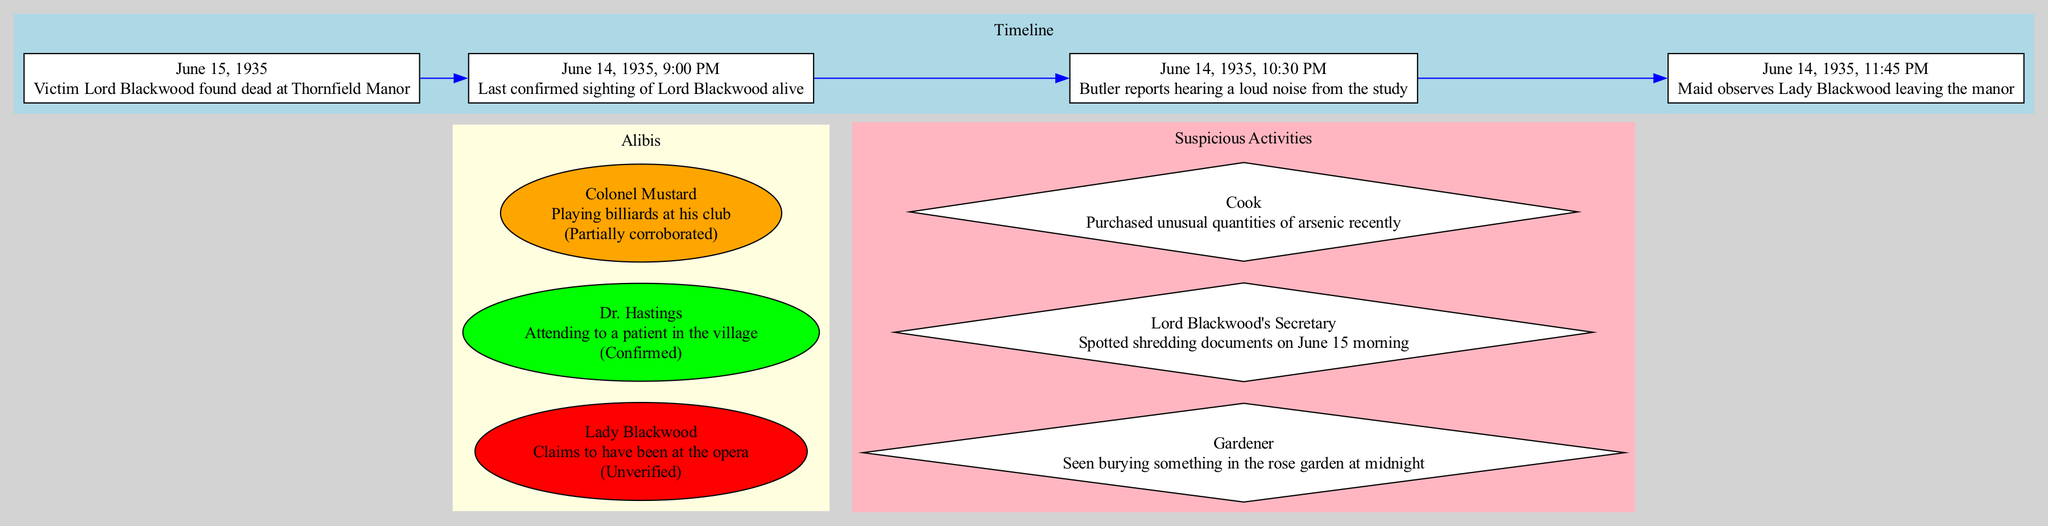What is the date of the victim's death? The timeline shows that on June 15, 1935, the victim, Lord Blackwood, was found dead at Thornfield Manor.
Answer: June 15, 1935 What was the last confirmed sighting of Lord Blackwood? According to the timeline, the last confirmed sighting of Lord Blackwood alive was on June 14, 1935, at 9:00 PM.
Answer: June 14, 1935, 9:00 PM How many suspects have unverified alibis? By reviewing the alibi section, we find that only Lady Blackwood has an unverified alibi, thus there is one suspect with this status.
Answer: 1 Which suspect’s alibi is confirmed? In the alibi section of the diagram, it states that Dr. Hastings has an alibi that is confirmed, making him the suspect with a verified alibi.
Answer: Dr. Hastings What suspicious activity is associated with the Cook? The suspicious activities section mentions that the Cook purchased unusual quantities of arsenic recently, linking this activity specifically to the Cook.
Answer: Purchased unusual quantities of arsenic recently Who was observed leaving the manor, and at what time? According to the timeline, the maid observed Lady Blackwood leaving the manor at 11:45 PM on June 14, 1935.
Answer: Lady Blackwood, 11:45 PM, June 14, 1935 Which suspect's alibi was partially corroborated? The diagram indicates that Colonel Mustard's alibi is only partially corroborated regarding his activity at the billiards club, establishing him as the suspect with partial confirmation.
Answer: Colonel Mustard What activity did the Gardener perform at midnight? From the suspicious activities listed, the Gardener was seen burying something in the rose garden at midnight, clearly identifying this activity.
Answer: Seen burying something in the rose garden at midnight 